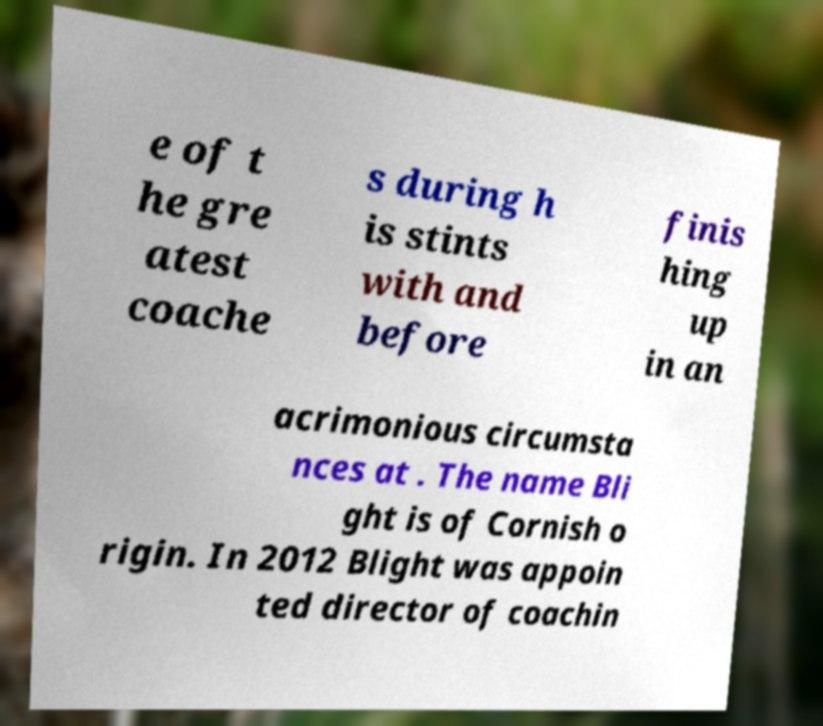What messages or text are displayed in this image? I need them in a readable, typed format. e of t he gre atest coache s during h is stints with and before finis hing up in an acrimonious circumsta nces at . The name Bli ght is of Cornish o rigin. In 2012 Blight was appoin ted director of coachin 